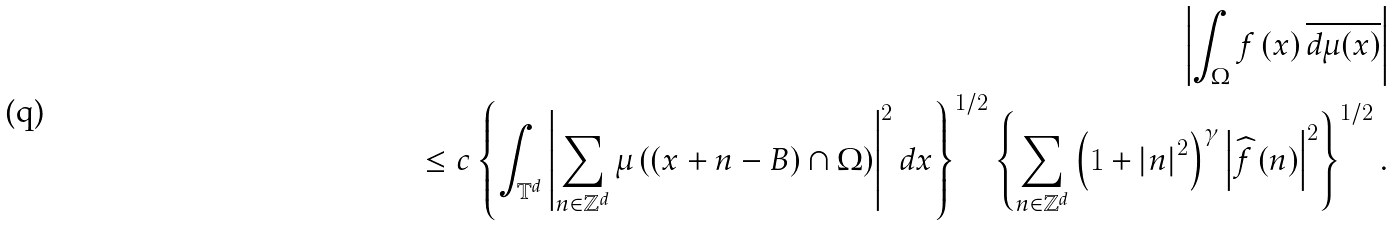<formula> <loc_0><loc_0><loc_500><loc_500>\left | \int _ { \Omega } f \left ( x \right ) \overline { d \mu ( x ) } \right | \\ \leq c \left \{ \int _ { \mathbb { T } ^ { d } } \left | \sum _ { n \in \mathbb { Z } ^ { d } } \mu \left ( \left ( x + n - B \right ) \cap \Omega \right ) \right | ^ { 2 } d x \right \} ^ { 1 / 2 } \left \{ \sum _ { n \in \mathbb { Z } ^ { d } } \left ( 1 + \left | n \right | ^ { 2 } \right ) ^ { \gamma } \left | \widehat { f } \left ( n \right ) \right | ^ { 2 } \right \} ^ { 1 / 2 } .</formula> 